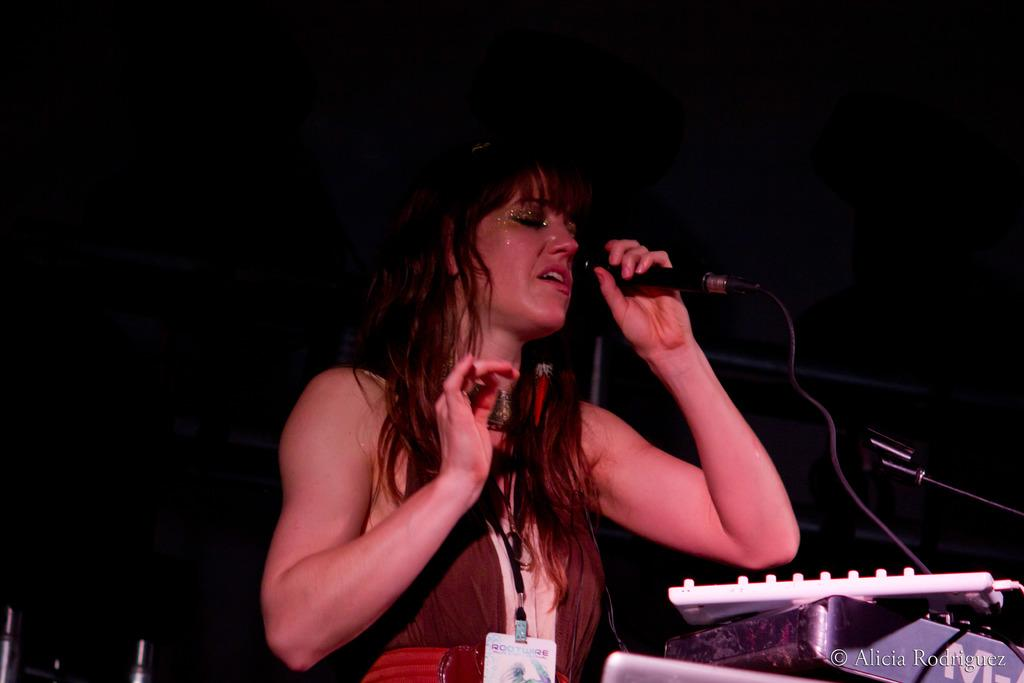What is the gender of the person in the image? The person in the image is a lady. What is the lady person wearing? The lady person is wearing a brown dress. What is the lady person holding in her hands? The lady person is holding an ID card and a remote. What is the lady person doing in the image? The lady person is singing. What can be seen in front of the lady person? There are musical instruments in front of her. What type of liquid is being poured out of the celery in the image? There is no liquid or celery present in the image; it features a lady person singing with musical instruments in front of her. 